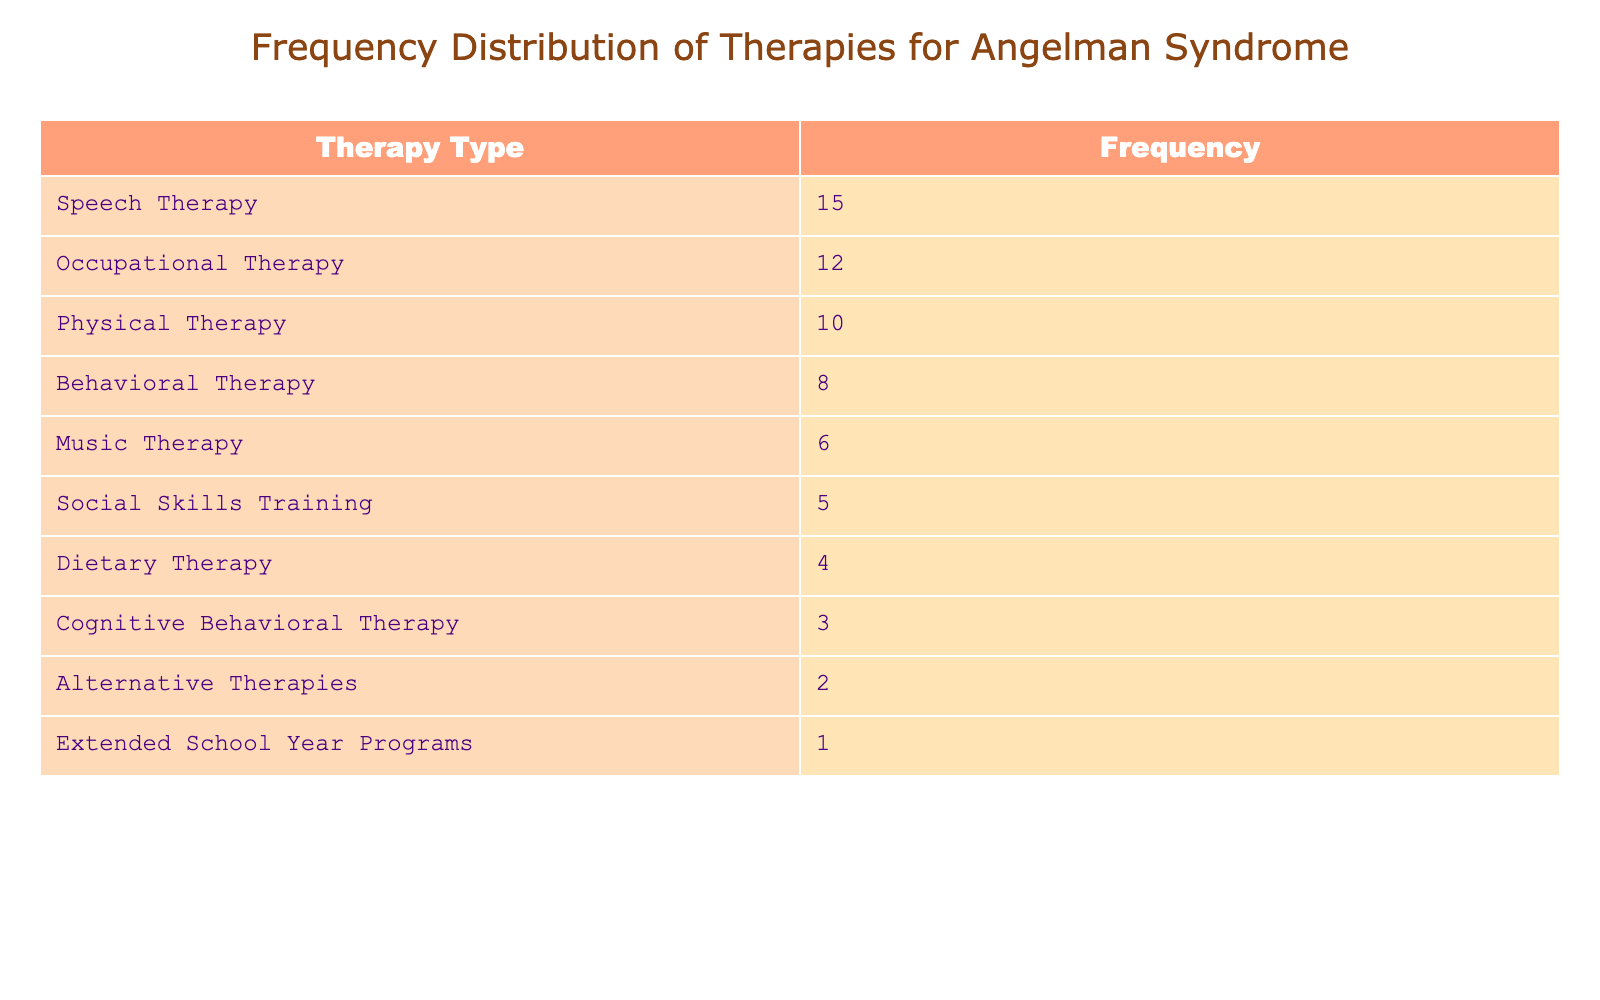What is the most commonly used therapy for children with Angelman Syndrome? The table shows various types of therapies along with their frequencies. By looking at the 'Frequency' column, we can see that 'Speech Therapy' has the highest frequency of 15, making it the most commonly used therapy.
Answer: Speech Therapy How many fewer instances of Dietary Therapy are reported compared to Behavioral Therapy? The frequency of Dietary Therapy is 4 and the frequency of Behavioral Therapy is 8. To find the difference, we subtract the frequency of Dietary Therapy from Behavioral Therapy: 8 - 4 = 4.
Answer: 4 Is Cognitive Behavioral Therapy used more frequently than Alternative Therapies? The frequency of Cognitive Behavioral Therapy is 3 and the frequency of Alternative Therapies is 2. Since 3 is greater than 2, we can conclude that Cognitive Behavioral Therapy is indeed used more frequently.
Answer: Yes What is the total frequency of all types of therapies listed? To find the total frequency, we need to sum all the individual frequencies: 15 + 12 + 10 + 8 + 6 + 5 + 4 + 3 + 2 + 1 = 66. Thus, the total frequency of all therapies is 66.
Answer: 66 Which two therapy types combined have the same frequency as Physical Therapy? The frequency of Physical Therapy is 10. If we check the combinations, Occupational Therapy (12) and Behavioral Therapy (8) exceeds that total, while Speech Therapy (15) is too high. The combinations of Music Therapy (6) and Social Skills Training (5) also sum to 11, and thus we look further. Dietary Therapy (4) added to Music Therapy (6) totals 10. Therefore, Music Therapy and Dietary Therapy combined equal the frequency of Physical Therapy.
Answer: Music Therapy and Dietary Therapy What is the least used type of therapy mentioned in this table? By examining the frequencies, we see the lowest entry for 'Extended School Year Programs' with a frequency of 1. Hence, this is the least used therapy.
Answer: Extended School Year Programs 